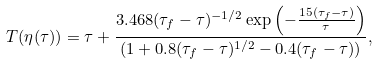Convert formula to latex. <formula><loc_0><loc_0><loc_500><loc_500>T ( \eta ( \tau ) ) = \tau + \frac { 3 . 4 6 8 ( \tau _ { f } - \tau ) ^ { - 1 / 2 } \exp \left ( - \frac { 1 5 ( \tau _ { f } - \tau ) } { \tau } \right ) } { ( 1 + 0 . 8 ( \tau _ { f } - \tau ) ^ { 1 / 2 } - 0 . 4 ( \tau _ { f } - \tau ) ) } ,</formula> 